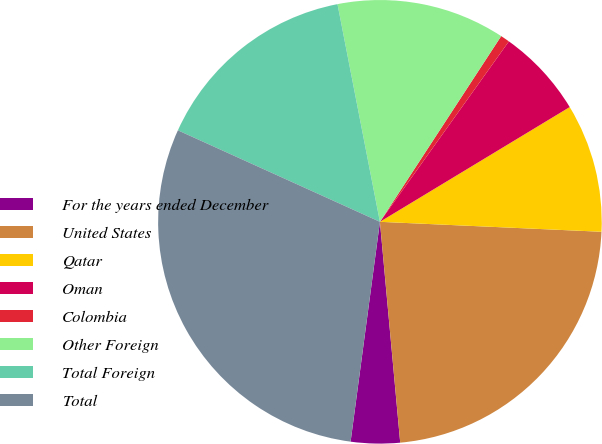Convert chart. <chart><loc_0><loc_0><loc_500><loc_500><pie_chart><fcel>For the years ended December<fcel>United States<fcel>Qatar<fcel>Oman<fcel>Colombia<fcel>Other Foreign<fcel>Total Foreign<fcel>Total<nl><fcel>3.57%<fcel>22.83%<fcel>9.37%<fcel>6.47%<fcel>0.67%<fcel>12.27%<fcel>15.17%<fcel>29.66%<nl></chart> 